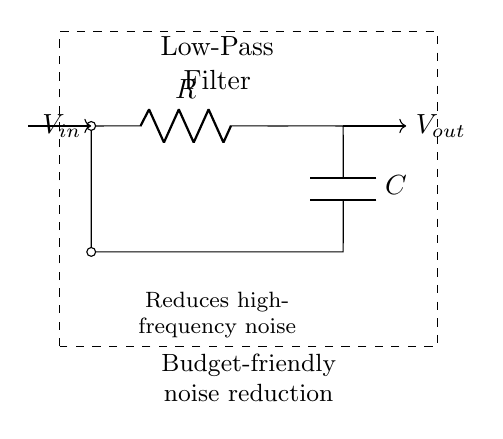What does the circuit consist of? The circuit consists of a resistor and a capacitor, which are connected in series. The resistor is labeled R, and the capacitor is labeled C.
Answer: resistor and capacitor What is the purpose of the low-pass filter? The purpose of the low-pass filter is to reduce high-frequency noise, allowing lower frequencies to pass through while attenuating higher frequencies.
Answer: reduce high-frequency noise What is the input signal voltage? The input signal voltage is represented as Vin, which connects to the circuit's input terminal.
Answer: Vin What type of filter is used in this circuit? This circuit is a low-pass filter, which means it allows signals with a frequency lower than a certain cutoff frequency to pass while attenuating frequencies higher than that.
Answer: low-pass filter How does the capacitor affect high frequencies? The capacitor allows high-frequency signals to discharge quickly, which results in attenuation of these frequencies in the output signal.
Answer: attenuates high frequencies What happens when the resistance value (R) is increased? Increasing the resistance value will lower the cutoff frequency of the filter, allowing fewer high frequencies to pass through the output.
Answer: lowers cutoff frequency What is the configuration of the components in the circuit? The components are arranged in a series configuration, with the resistor followed by the capacitor leading to the output terminal.
Answer: series configuration 